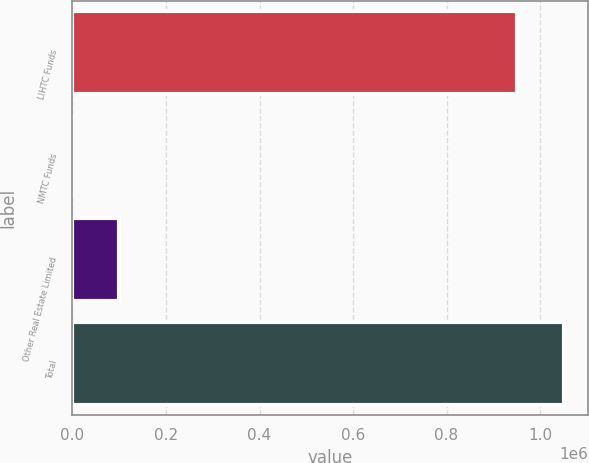Convert chart to OTSL. <chart><loc_0><loc_0><loc_500><loc_500><bar_chart><fcel>LIHTC Funds<fcel>NMTC Funds<fcel>Other Real Estate Limited<fcel>Total<nl><fcel>951465<fcel>40<fcel>98892.7<fcel>1.05032e+06<nl></chart> 